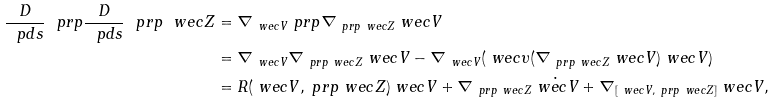Convert formula to latex. <formula><loc_0><loc_0><loc_500><loc_500>\frac { D } { \ p d s } \ p r p \frac { D } { \ p d s } \ p r p \ w e c { Z } & = \nabla _ { \ w e c { V } } \ p r p \nabla _ { \ p r p \ w e c { Z } } \ w e c { V } \\ & = \nabla _ { \ w e c { V } } \nabla _ { \ p r p \ w e c { Z } } \ w e c { V } - \nabla _ { \ w e c { V } } ( \ w e c { \upsilon } ( \nabla _ { \ p r p \ w e c { Z } } \ w e c { V } ) \ w e c { V } ) \\ & = R ( \ w e c { V } , \ p r p \ w e c { Z } ) \ w e c { V } + \nabla _ { \ p r p \ w e c { Z } } \dot { \ w e c { V } } + \nabla _ { [ \ w e c { V } , \ p r p \ w e c { Z } ] } \ w e c { V } ,</formula> 